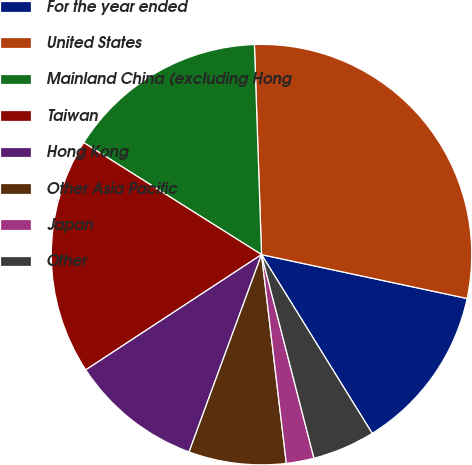Convert chart. <chart><loc_0><loc_0><loc_500><loc_500><pie_chart><fcel>For the year ended<fcel>United States<fcel>Mainland China (excluding Hong<fcel>Taiwan<fcel>Hong Kong<fcel>Other Asia Pacific<fcel>Japan<fcel>Other<nl><fcel>12.83%<fcel>28.88%<fcel>15.51%<fcel>18.18%<fcel>10.16%<fcel>7.48%<fcel>2.13%<fcel>4.81%<nl></chart> 